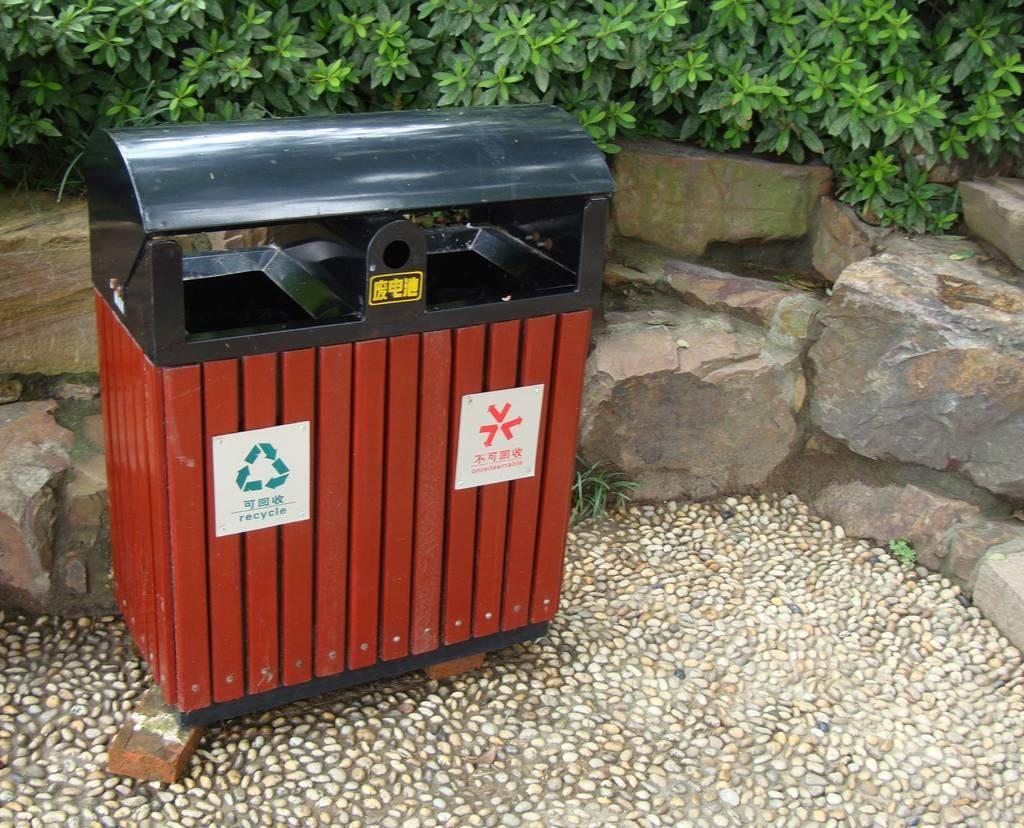<image>
Write a terse but informative summary of the picture. Recycling bin beside a low rock wall sitting on two wood boards. 